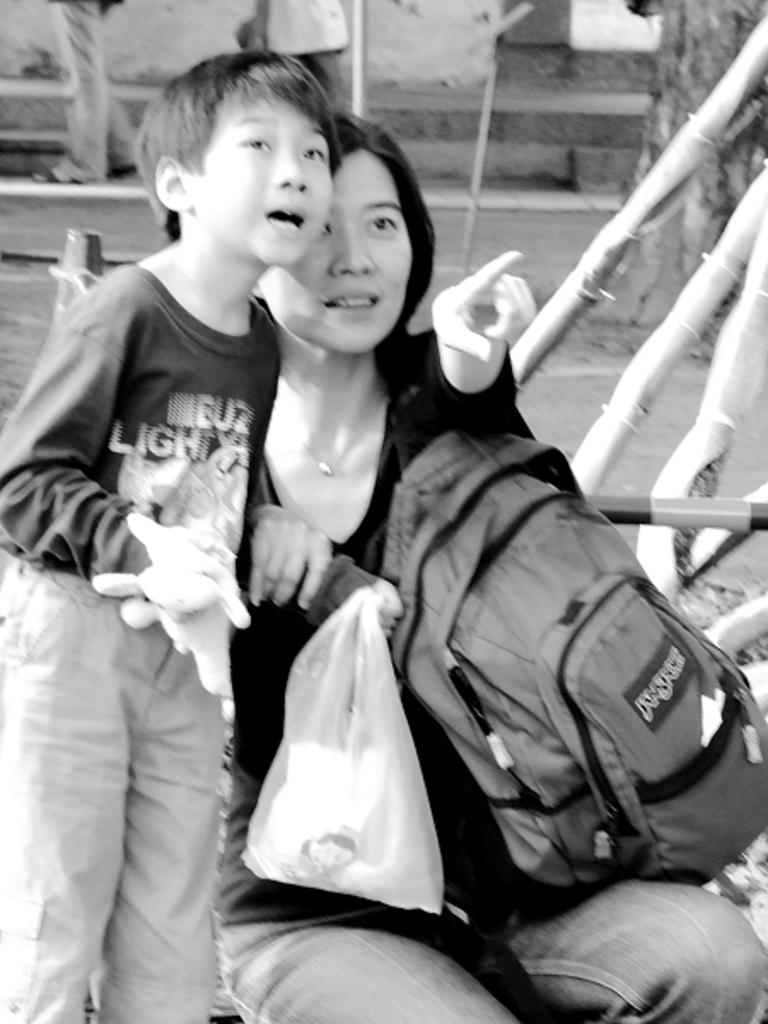How many people are present in the image? There are two persons in the image. What object can be seen in the image besides the two persons? There is a bag and a cover visible in the image. What can be seen in the background of the image? The background of the image includes other persons standing. What is the color scheme of the image? The image is in black and white. Where is the ornament located in the image? There is no ornament present in the image. What type of turkey can be seen in the image? There is no turkey present in the image. 